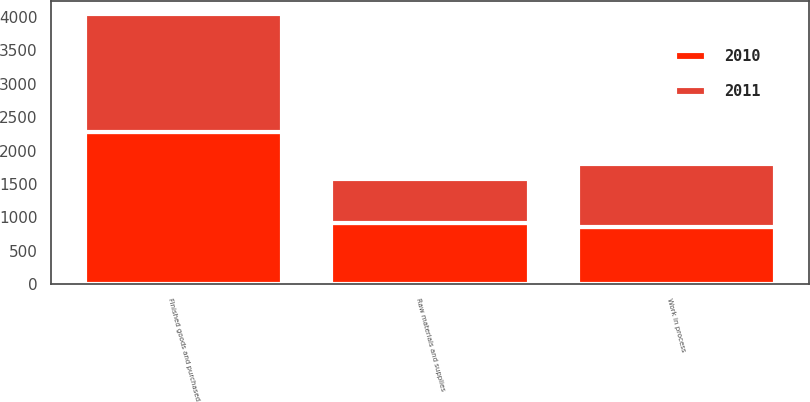Convert chart to OTSL. <chart><loc_0><loc_0><loc_500><loc_500><stacked_bar_chart><ecel><fcel>Raw materials and supplies<fcel>Work in process<fcel>Finished goods and purchased<nl><fcel>2010<fcel>907<fcel>852<fcel>2271<nl><fcel>2011<fcel>661<fcel>953<fcel>1774<nl></chart> 